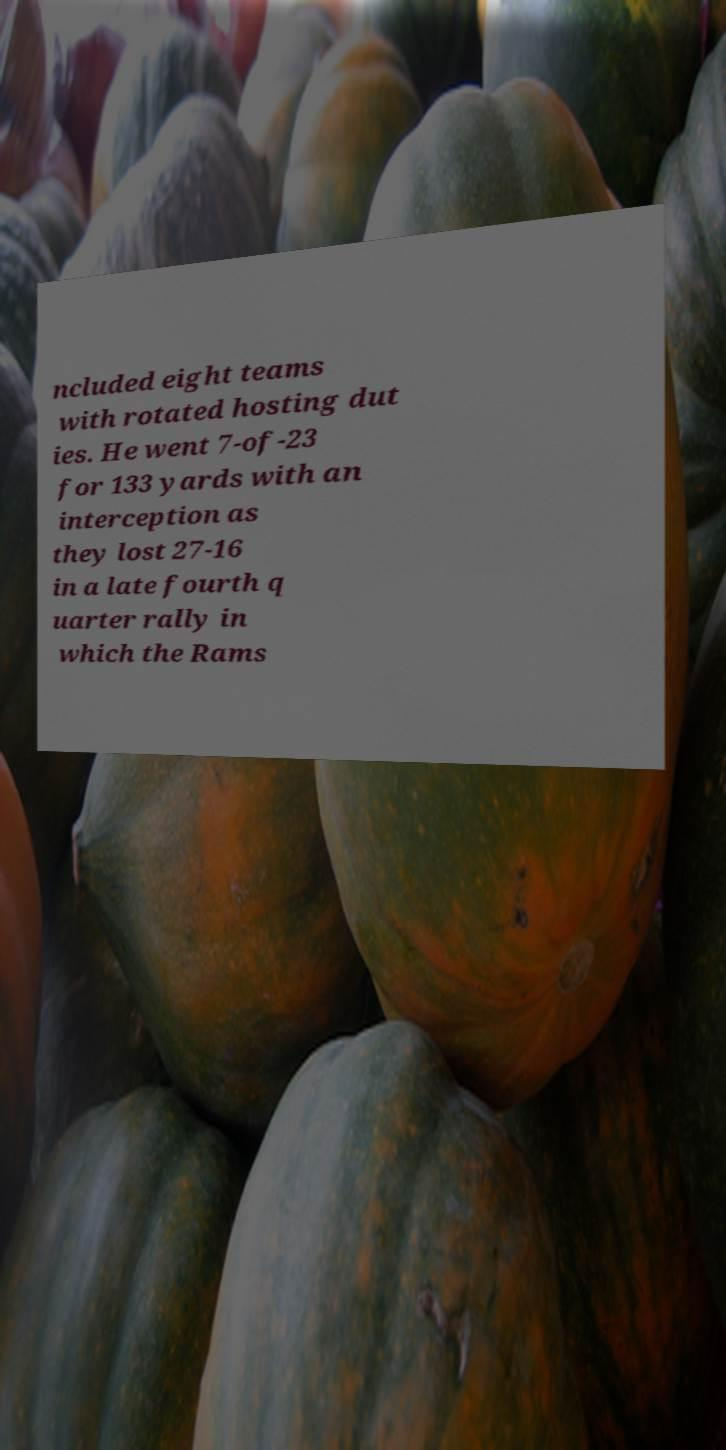Please read and relay the text visible in this image. What does it say? ncluded eight teams with rotated hosting dut ies. He went 7-of-23 for 133 yards with an interception as they lost 27-16 in a late fourth q uarter rally in which the Rams 